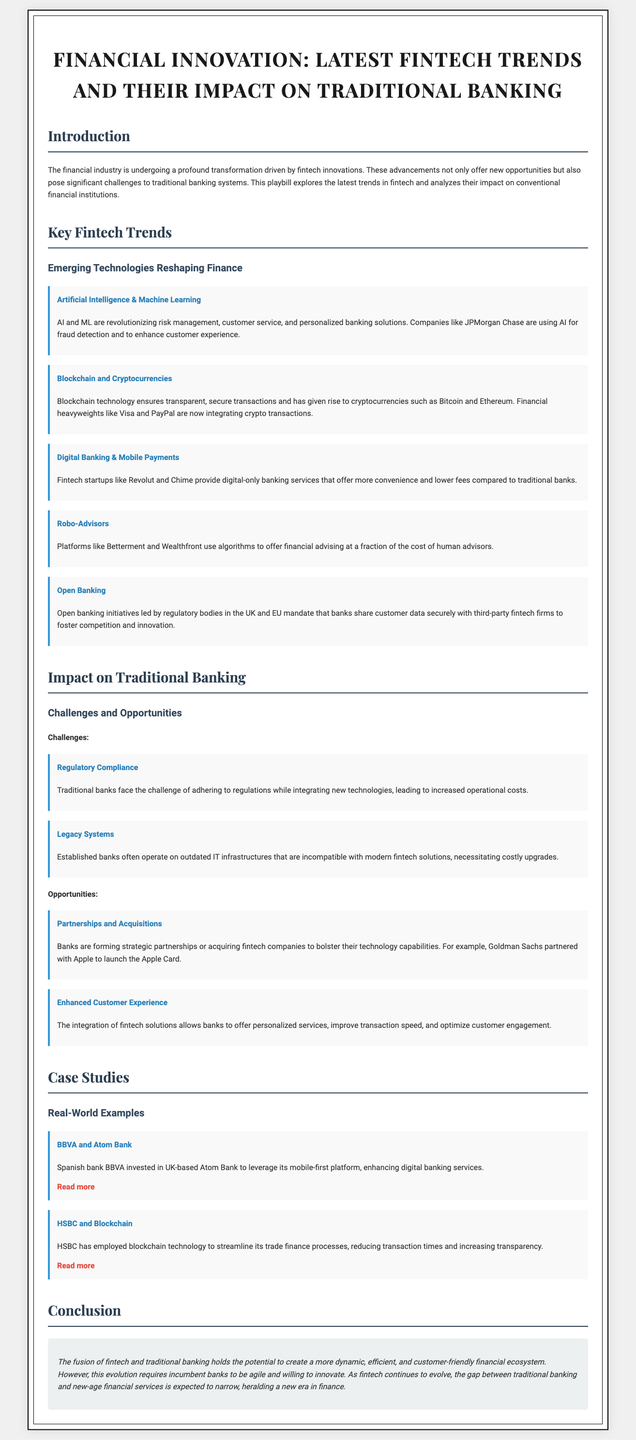What is the title of the document? The title is stated in the header of the playbill.
Answer: Financial Innovation: Latest Fintech Trends and Their Impact on Traditional Banking Who are two companies using AI for fraud detection? Companies leveraging AI are mentioned in the "Key Fintech Trends" section.
Answer: JPMorgan Chase What does blockchain technology ensure? This is described in the section about blockchain and cryptocurrencies.
Answer: Transparent, secure transactions What is a challenge faced by traditional banks? The challenges are listed under the impact on traditional banking section.
Answer: Regulatory Compliance Which fintech startup provides digital-only banking services? The specific startup is noted in the digital banking and mobile payments trend.
Answer: Revolut What is one opportunity for banks mentioned? Opportunities are highlighted in the impact section of traditional banking.
Answer: Partnerships and Acquisitions What technology has HSBC employed for trade finance? The technology used by HSBC is discussed in the case studies.
Answer: Blockchain What is the potential benefit of integrating fintech solutions for banks? The benefit is mentioned under "Enhanced Customer Experience."
Answer: Personalized services 